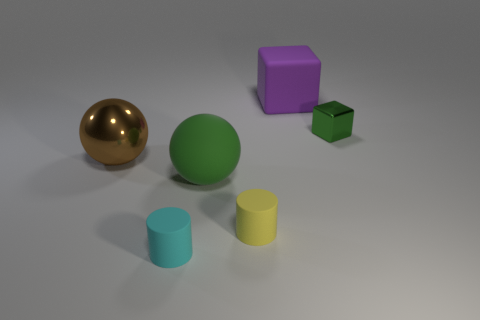Add 4 small metal blocks. How many objects exist? 10 Subtract all spheres. How many objects are left? 4 Subtract 0 yellow cubes. How many objects are left? 6 Subtract all cyan things. Subtract all tiny cyan cylinders. How many objects are left? 4 Add 3 tiny metallic objects. How many tiny metallic objects are left? 4 Add 3 green cubes. How many green cubes exist? 4 